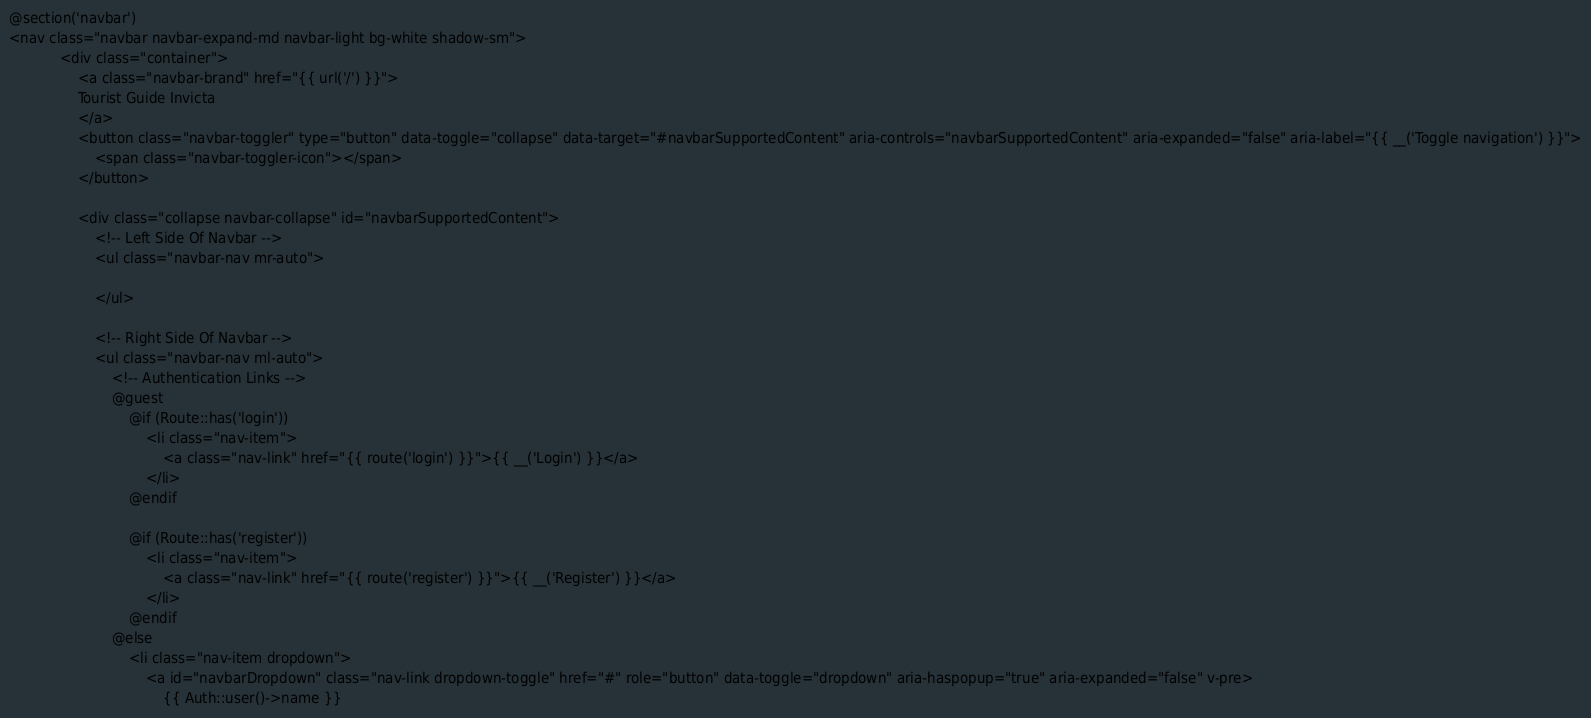Convert code to text. <code><loc_0><loc_0><loc_500><loc_500><_PHP_>@section('navbar')
<nav class="navbar navbar-expand-md navbar-light bg-white shadow-sm">
            <div class="container">
                <a class="navbar-brand" href="{{ url('/') }}">
                Tourist Guide Invicta
                </a>
                <button class="navbar-toggler" type="button" data-toggle="collapse" data-target="#navbarSupportedContent" aria-controls="navbarSupportedContent" aria-expanded="false" aria-label="{{ __('Toggle navigation') }}">
                    <span class="navbar-toggler-icon"></span>
                </button>

                <div class="collapse navbar-collapse" id="navbarSupportedContent">
                    <!-- Left Side Of Navbar -->
                    <ul class="navbar-nav mr-auto">

                    </ul>

                    <!-- Right Side Of Navbar -->
                    <ul class="navbar-nav ml-auto">
                        <!-- Authentication Links -->
                        @guest
                            @if (Route::has('login'))
                                <li class="nav-item">
                                    <a class="nav-link" href="{{ route('login') }}">{{ __('Login') }}</a>
                                </li>
                            @endif
                            
                            @if (Route::has('register'))
                                <li class="nav-item">
                                    <a class="nav-link" href="{{ route('register') }}">{{ __('Register') }}</a>
                                </li>
                            @endif
                        @else
                            <li class="nav-item dropdown">
                                <a id="navbarDropdown" class="nav-link dropdown-toggle" href="#" role="button" data-toggle="dropdown" aria-haspopup="true" aria-expanded="false" v-pre>
                                    {{ Auth::user()->name }}</code> 